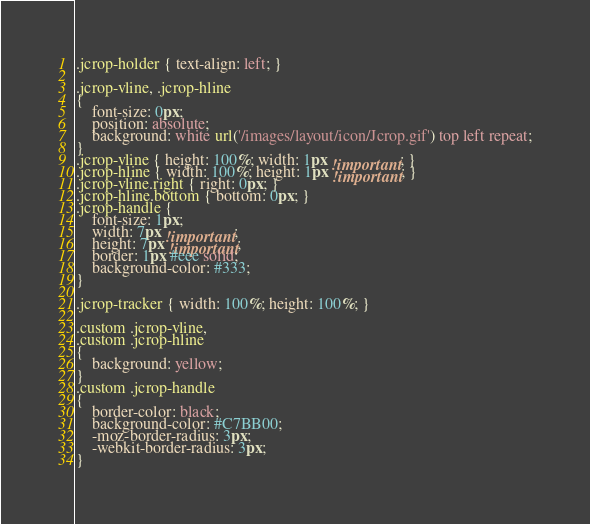<code> <loc_0><loc_0><loc_500><loc_500><_CSS_>.jcrop-holder { text-align: left; }

.jcrop-vline, .jcrop-hline
{
	font-size: 0px;
	position: absolute;
	background: white url('/images/layout/icon/Jcrop.gif') top left repeat;
}
.jcrop-vline { height: 100%; width: 1px !important; }
.jcrop-hline { width: 100%; height: 1px !important; }
.jcrop-vline.right { right: 0px; }
.jcrop-hline.bottom { bottom: 0px; }
.jcrop-handle {
	font-size: 1px;
	width: 7px !important;
	height: 7px !important;
	border: 1px #eee solid;
	background-color: #333;
}

.jcrop-tracker { width: 100%; height: 100%; }

.custom .jcrop-vline,
.custom .jcrop-hline
{
	background: yellow;
}
.custom .jcrop-handle
{
	border-color: black;
	background-color: #C7BB00;
	-moz-border-radius: 3px;
	-webkit-border-radius: 3px;
}
</code> 